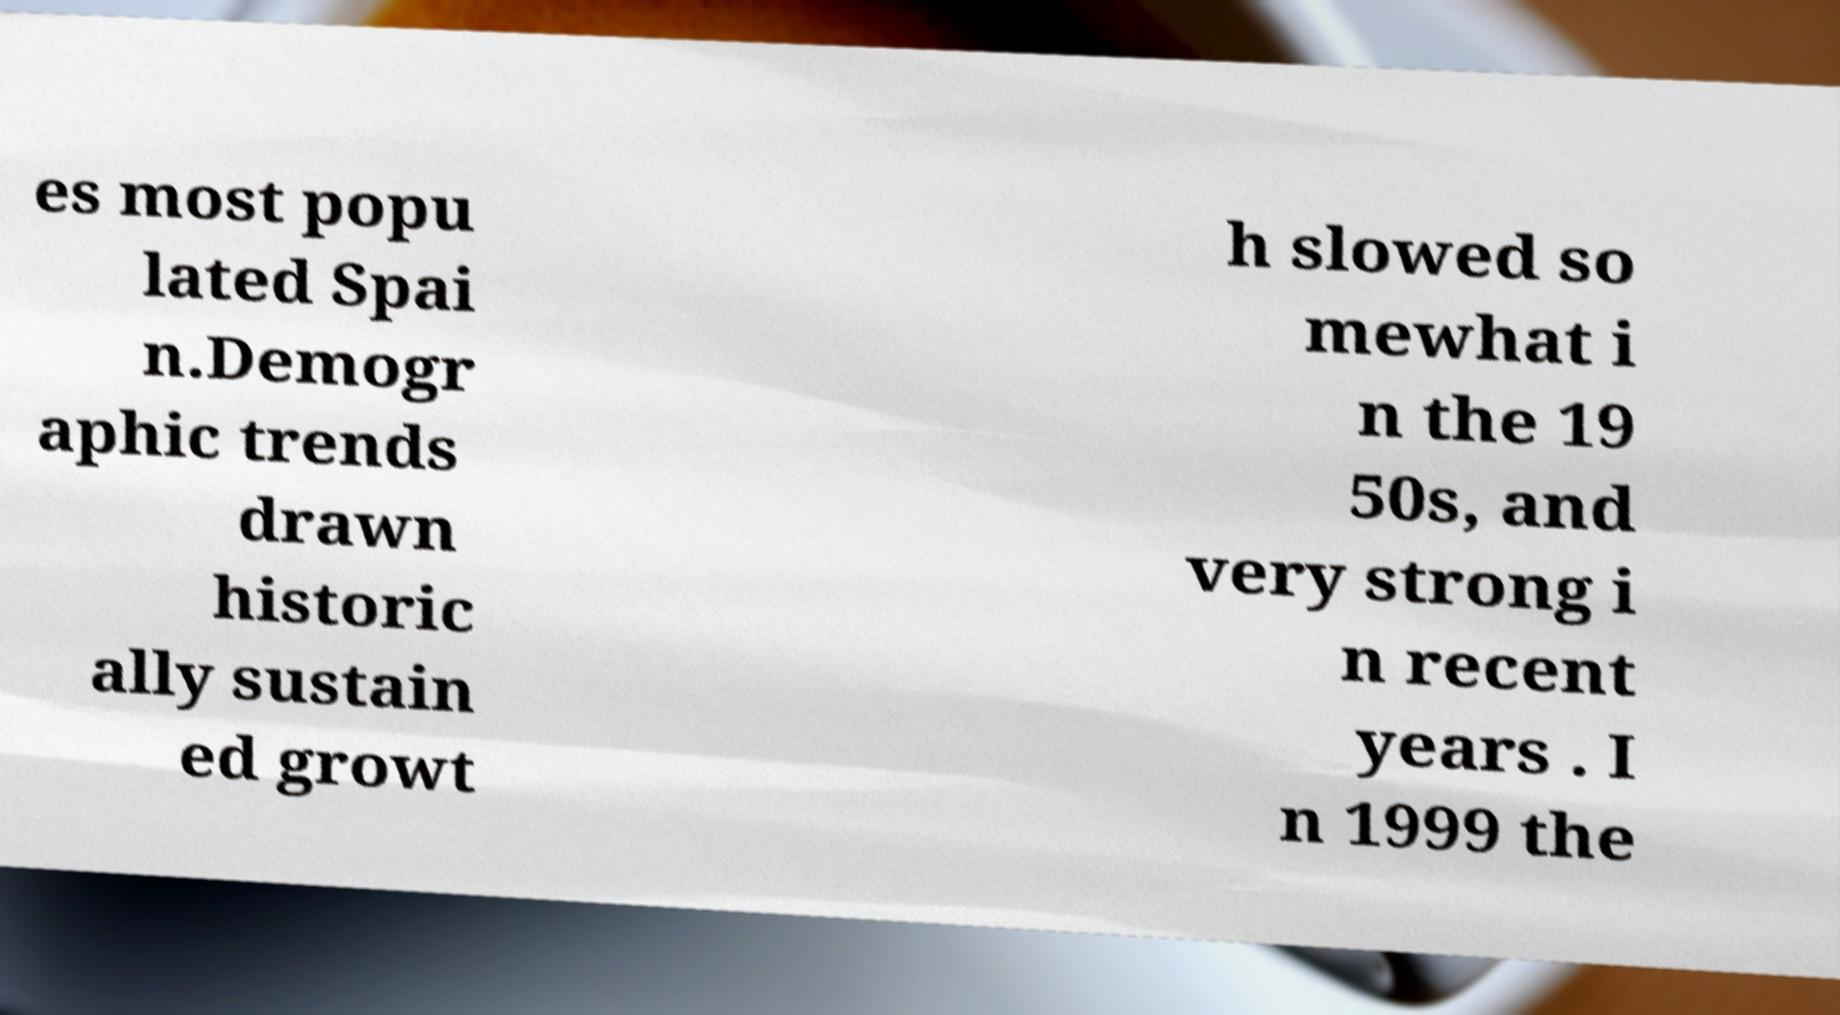Could you extract and type out the text from this image? es most popu lated Spai n.Demogr aphic trends drawn historic ally sustain ed growt h slowed so mewhat i n the 19 50s, and very strong i n recent years . I n 1999 the 